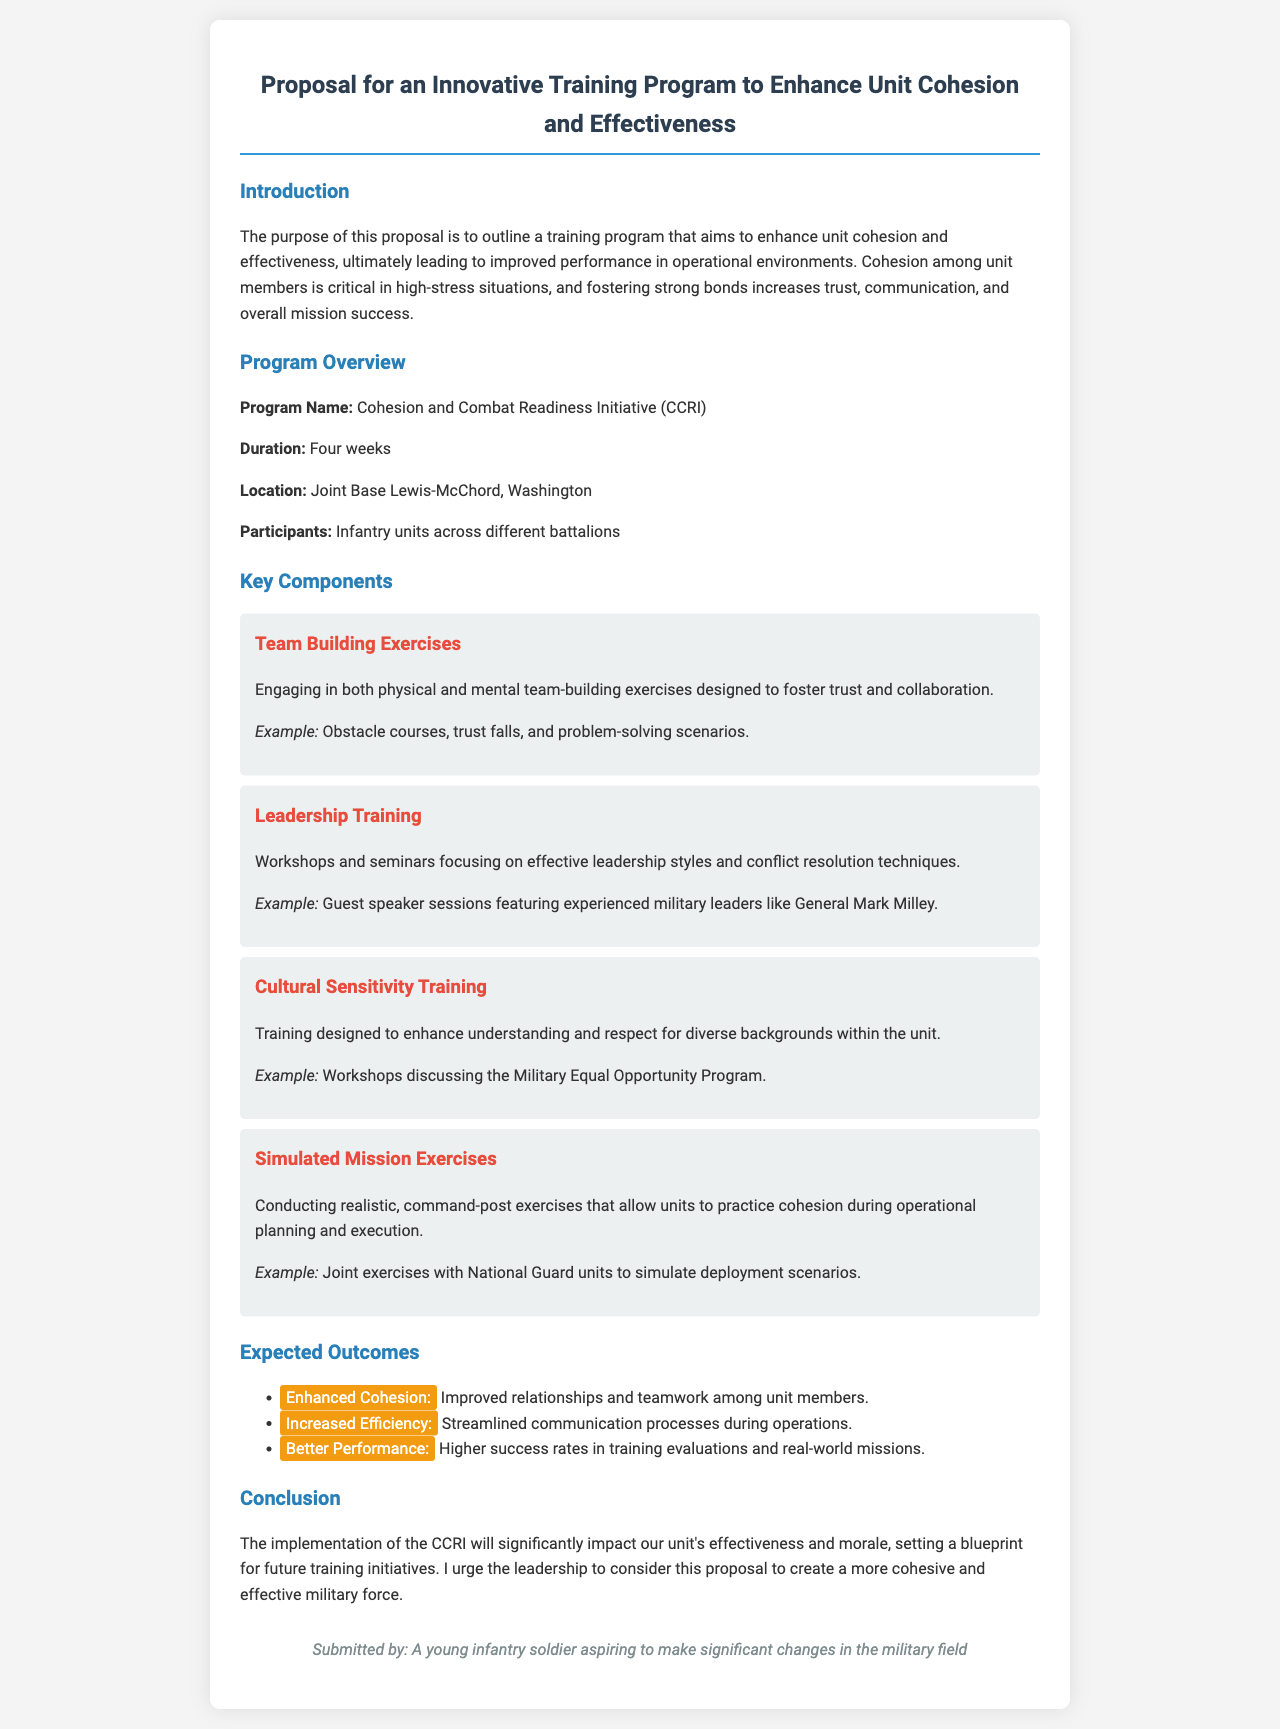What is the name of the training program? The program is referred to as the "Cohesion and Combat Readiness Initiative (CCRI)" in the document.
Answer: Cohesion and Combat Readiness Initiative (CCRI) How long is the training program? The duration of the program, as stated in the document, is four weeks.
Answer: Four weeks Where will the training take place? The document specifies that the location for the training is Joint Base Lewis-McChord, Washington.
Answer: Joint Base Lewis-McChord, Washington What is a key component of the program related to team dynamics? The document lists "Team Building Exercises" as a key component designed to foster trust and collaboration among unit members.
Answer: Team Building Exercises Who is mentioned as a guest speaker in the leadership training component? The document includes General Mark Milley as a guest speaker featured in leadership training sessions.
Answer: General Mark Milley What is one expected outcome of the program related to communication? The program aims to streamline communication processes during operations as one of its expected outcomes.
Answer: Streamlined communication processes What aspect of training promotes understanding of diverse backgrounds? The document specifies "Cultural Sensitivity Training" as a program component that enhances understanding and respect for diverse backgrounds within the unit.
Answer: Cultural Sensitivity Training How does the proposal conclude? The conclusion emphasizes the significant impact of the CCRI on effectiveness and morale, urging leadership to consider implementation.
Answer: Significant impact on effectiveness and morale What is the purpose of this proposal? The purpose outlined in the document is to enhance unit cohesion and effectiveness for improved performance in operational environments.
Answer: Enhance unit cohesion and effectiveness 